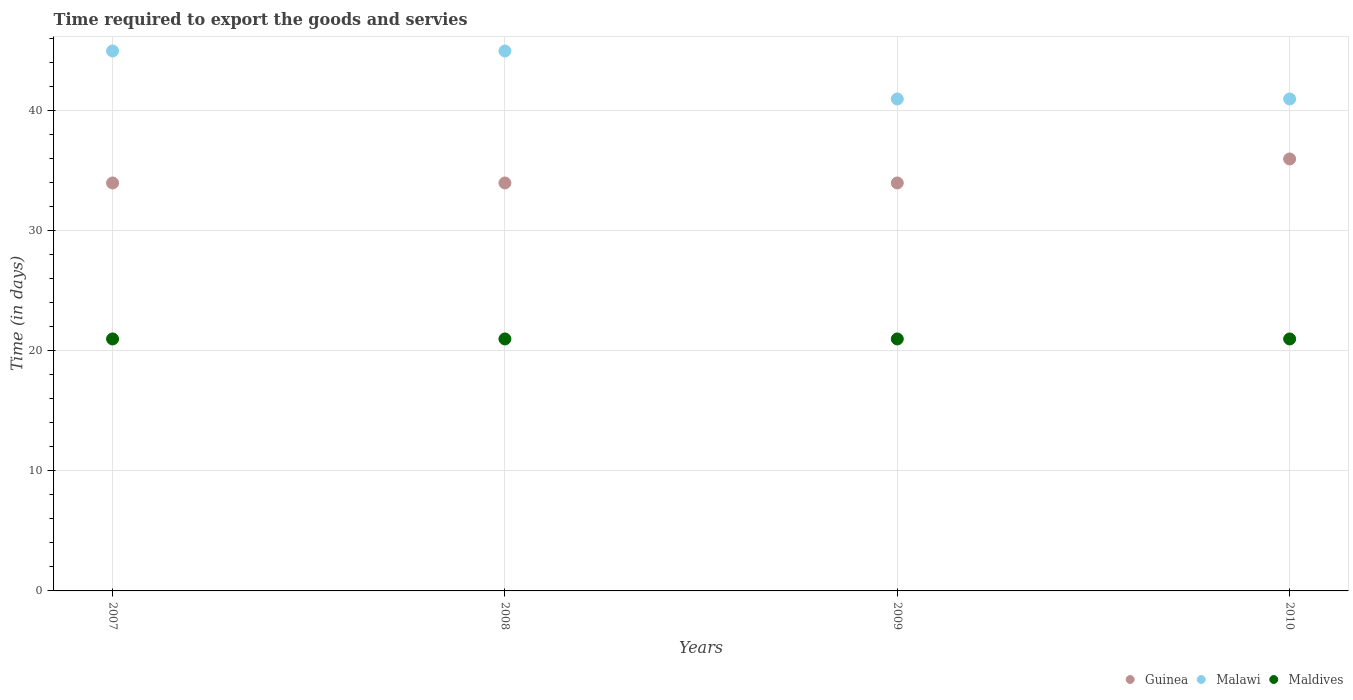How many different coloured dotlines are there?
Give a very brief answer. 3. What is the number of days required to export the goods and services in Guinea in 2009?
Give a very brief answer. 34. Across all years, what is the maximum number of days required to export the goods and services in Malawi?
Offer a very short reply. 45. Across all years, what is the minimum number of days required to export the goods and services in Maldives?
Offer a terse response. 21. In which year was the number of days required to export the goods and services in Malawi maximum?
Offer a very short reply. 2007. In which year was the number of days required to export the goods and services in Maldives minimum?
Provide a succinct answer. 2007. What is the total number of days required to export the goods and services in Maldives in the graph?
Make the answer very short. 84. What is the difference between the number of days required to export the goods and services in Malawi in 2010 and the number of days required to export the goods and services in Guinea in 2009?
Provide a succinct answer. 7. In the year 2009, what is the difference between the number of days required to export the goods and services in Maldives and number of days required to export the goods and services in Malawi?
Give a very brief answer. -20. What is the ratio of the number of days required to export the goods and services in Guinea in 2007 to that in 2010?
Give a very brief answer. 0.94. What is the difference between the highest and the second highest number of days required to export the goods and services in Malawi?
Give a very brief answer. 0. Is the sum of the number of days required to export the goods and services in Malawi in 2009 and 2010 greater than the maximum number of days required to export the goods and services in Guinea across all years?
Provide a short and direct response. Yes. Does the number of days required to export the goods and services in Guinea monotonically increase over the years?
Give a very brief answer. No. Is the number of days required to export the goods and services in Guinea strictly less than the number of days required to export the goods and services in Malawi over the years?
Your response must be concise. Yes. How many dotlines are there?
Give a very brief answer. 3. How many years are there in the graph?
Provide a succinct answer. 4. What is the difference between two consecutive major ticks on the Y-axis?
Make the answer very short. 10. Does the graph contain grids?
Ensure brevity in your answer.  Yes. Where does the legend appear in the graph?
Your response must be concise. Bottom right. How many legend labels are there?
Ensure brevity in your answer.  3. What is the title of the graph?
Provide a short and direct response. Time required to export the goods and servies. What is the label or title of the X-axis?
Keep it short and to the point. Years. What is the label or title of the Y-axis?
Provide a short and direct response. Time (in days). What is the Time (in days) in Guinea in 2007?
Offer a very short reply. 34. What is the Time (in days) in Malawi in 2007?
Provide a succinct answer. 45. What is the Time (in days) of Maldives in 2007?
Offer a very short reply. 21. What is the Time (in days) of Maldives in 2008?
Your answer should be very brief. 21. What is the Time (in days) of Maldives in 2010?
Your response must be concise. 21. Across all years, what is the maximum Time (in days) in Maldives?
Keep it short and to the point. 21. Across all years, what is the minimum Time (in days) of Guinea?
Give a very brief answer. 34. Across all years, what is the minimum Time (in days) in Malawi?
Ensure brevity in your answer.  41. What is the total Time (in days) in Guinea in the graph?
Ensure brevity in your answer.  138. What is the total Time (in days) in Malawi in the graph?
Your answer should be very brief. 172. What is the total Time (in days) of Maldives in the graph?
Offer a terse response. 84. What is the difference between the Time (in days) in Guinea in 2007 and that in 2008?
Offer a very short reply. 0. What is the difference between the Time (in days) in Malawi in 2007 and that in 2008?
Your answer should be compact. 0. What is the difference between the Time (in days) in Malawi in 2007 and that in 2009?
Offer a terse response. 4. What is the difference between the Time (in days) in Malawi in 2007 and that in 2010?
Your response must be concise. 4. What is the difference between the Time (in days) in Guinea in 2008 and that in 2009?
Give a very brief answer. 0. What is the difference between the Time (in days) of Maldives in 2008 and that in 2009?
Ensure brevity in your answer.  0. What is the difference between the Time (in days) in Maldives in 2009 and that in 2010?
Give a very brief answer. 0. What is the difference between the Time (in days) of Guinea in 2007 and the Time (in days) of Malawi in 2008?
Provide a short and direct response. -11. What is the difference between the Time (in days) in Malawi in 2007 and the Time (in days) in Maldives in 2008?
Provide a short and direct response. 24. What is the difference between the Time (in days) in Guinea in 2007 and the Time (in days) in Malawi in 2009?
Your answer should be very brief. -7. What is the difference between the Time (in days) of Guinea in 2007 and the Time (in days) of Maldives in 2009?
Ensure brevity in your answer.  13. What is the difference between the Time (in days) of Malawi in 2007 and the Time (in days) of Maldives in 2009?
Provide a succinct answer. 24. What is the difference between the Time (in days) in Malawi in 2007 and the Time (in days) in Maldives in 2010?
Keep it short and to the point. 24. What is the difference between the Time (in days) in Malawi in 2008 and the Time (in days) in Maldives in 2009?
Keep it short and to the point. 24. What is the difference between the Time (in days) in Guinea in 2008 and the Time (in days) in Malawi in 2010?
Make the answer very short. -7. What is the difference between the Time (in days) of Guinea in 2008 and the Time (in days) of Maldives in 2010?
Offer a terse response. 13. What is the difference between the Time (in days) in Malawi in 2008 and the Time (in days) in Maldives in 2010?
Ensure brevity in your answer.  24. What is the difference between the Time (in days) of Guinea in 2009 and the Time (in days) of Malawi in 2010?
Your response must be concise. -7. What is the difference between the Time (in days) of Guinea in 2009 and the Time (in days) of Maldives in 2010?
Provide a succinct answer. 13. What is the average Time (in days) of Guinea per year?
Offer a terse response. 34.5. What is the average Time (in days) in Malawi per year?
Your answer should be very brief. 43. In the year 2007, what is the difference between the Time (in days) in Guinea and Time (in days) in Maldives?
Provide a short and direct response. 13. In the year 2007, what is the difference between the Time (in days) of Malawi and Time (in days) of Maldives?
Your response must be concise. 24. In the year 2008, what is the difference between the Time (in days) in Guinea and Time (in days) in Malawi?
Your answer should be compact. -11. In the year 2008, what is the difference between the Time (in days) in Guinea and Time (in days) in Maldives?
Make the answer very short. 13. In the year 2008, what is the difference between the Time (in days) in Malawi and Time (in days) in Maldives?
Ensure brevity in your answer.  24. In the year 2009, what is the difference between the Time (in days) of Guinea and Time (in days) of Maldives?
Make the answer very short. 13. In the year 2010, what is the difference between the Time (in days) in Guinea and Time (in days) in Malawi?
Ensure brevity in your answer.  -5. In the year 2010, what is the difference between the Time (in days) of Guinea and Time (in days) of Maldives?
Give a very brief answer. 15. In the year 2010, what is the difference between the Time (in days) of Malawi and Time (in days) of Maldives?
Provide a short and direct response. 20. What is the ratio of the Time (in days) of Malawi in 2007 to that in 2008?
Your answer should be very brief. 1. What is the ratio of the Time (in days) in Guinea in 2007 to that in 2009?
Your response must be concise. 1. What is the ratio of the Time (in days) in Malawi in 2007 to that in 2009?
Your answer should be very brief. 1.1. What is the ratio of the Time (in days) in Guinea in 2007 to that in 2010?
Your response must be concise. 0.94. What is the ratio of the Time (in days) in Malawi in 2007 to that in 2010?
Your answer should be very brief. 1.1. What is the ratio of the Time (in days) in Malawi in 2008 to that in 2009?
Make the answer very short. 1.1. What is the ratio of the Time (in days) of Maldives in 2008 to that in 2009?
Offer a terse response. 1. What is the ratio of the Time (in days) in Guinea in 2008 to that in 2010?
Ensure brevity in your answer.  0.94. What is the ratio of the Time (in days) in Malawi in 2008 to that in 2010?
Ensure brevity in your answer.  1.1. What is the ratio of the Time (in days) of Maldives in 2008 to that in 2010?
Give a very brief answer. 1. What is the ratio of the Time (in days) in Guinea in 2009 to that in 2010?
Keep it short and to the point. 0.94. What is the ratio of the Time (in days) of Maldives in 2009 to that in 2010?
Make the answer very short. 1. What is the difference between the highest and the second highest Time (in days) in Maldives?
Your answer should be compact. 0. What is the difference between the highest and the lowest Time (in days) of Guinea?
Ensure brevity in your answer.  2. What is the difference between the highest and the lowest Time (in days) of Malawi?
Provide a short and direct response. 4. 